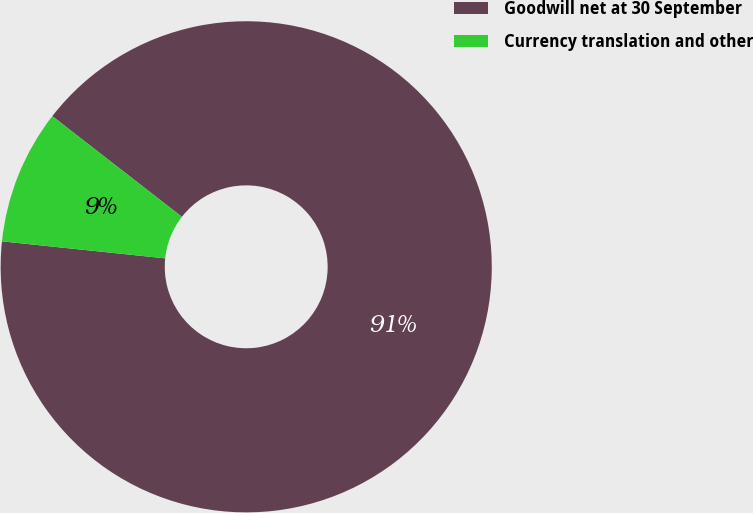Convert chart. <chart><loc_0><loc_0><loc_500><loc_500><pie_chart><fcel>Goodwill net at 30 September<fcel>Currency translation and other<nl><fcel>91.14%<fcel>8.86%<nl></chart> 